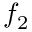Convert formula to latex. <formula><loc_0><loc_0><loc_500><loc_500>f _ { 2 }</formula> 